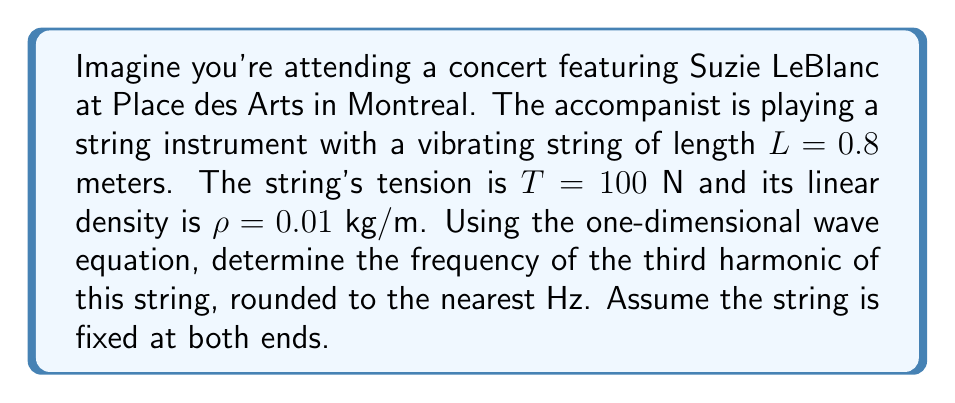Can you answer this question? To solve this problem, we'll use the one-dimensional wave equation and the properties of standing waves on a fixed string:

1) The one-dimensional wave equation is given by:

   $$\frac{\partial^2 y}{\partial t^2} = v^2 \frac{\partial^2 y}{\partial x^2}$$

   where $v$ is the wave speed.

2) The wave speed $v$ in a string is given by:

   $$v = \sqrt{\frac{T}{\rho}}$$

3) Substituting the given values:

   $$v = \sqrt{\frac{100 \text{ N}}{0.01 \text{ kg/m}}} = 100 \text{ m/s}$$

4) For a string fixed at both ends, the fundamental frequency $f_1$ is given by:

   $$f_1 = \frac{v}{2L}$$

5) Substituting our values:

   $$f_1 = \frac{100 \text{ m/s}}{2(0.8 \text{ m})} = 62.5 \text{ Hz}$$

6) The frequencies of the harmonics are integer multiples of the fundamental frequency. The third harmonic corresponds to $n=3$:

   $$f_3 = 3f_1 = 3(62.5 \text{ Hz}) = 187.5 \text{ Hz}$$

7) Rounding to the nearest Hz:

   $$f_3 \approx 188 \text{ Hz}$$
Answer: 188 Hz 